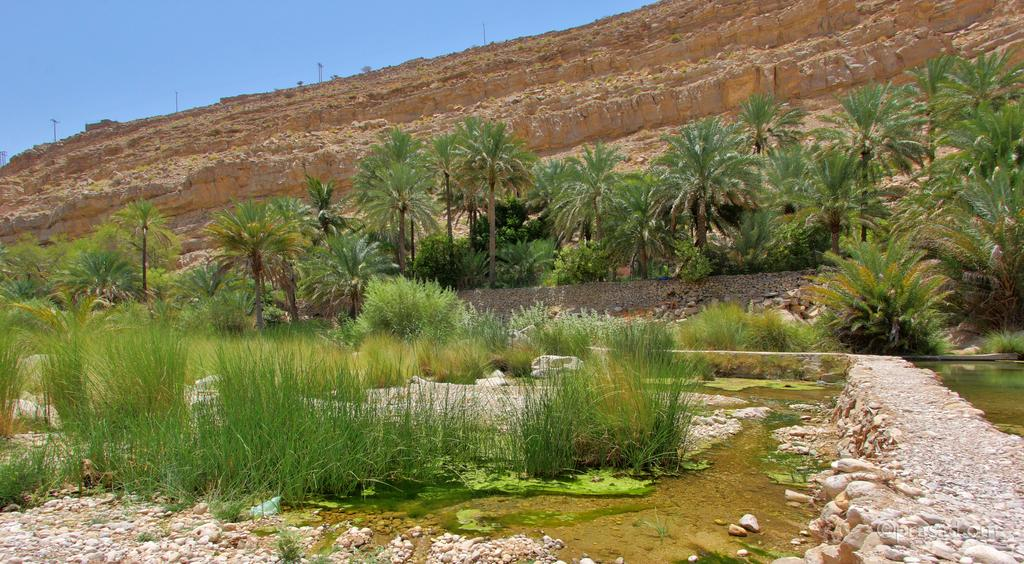What type of vegetation can be seen in the image? There are trees and bushes in the image. What else can be seen in the background of the image? There are poles and the sky visible in the background of the image. What type of verse is written on the shoes in the image? There are: There are no shoes present in the image, and therefore no verse can be observed. 